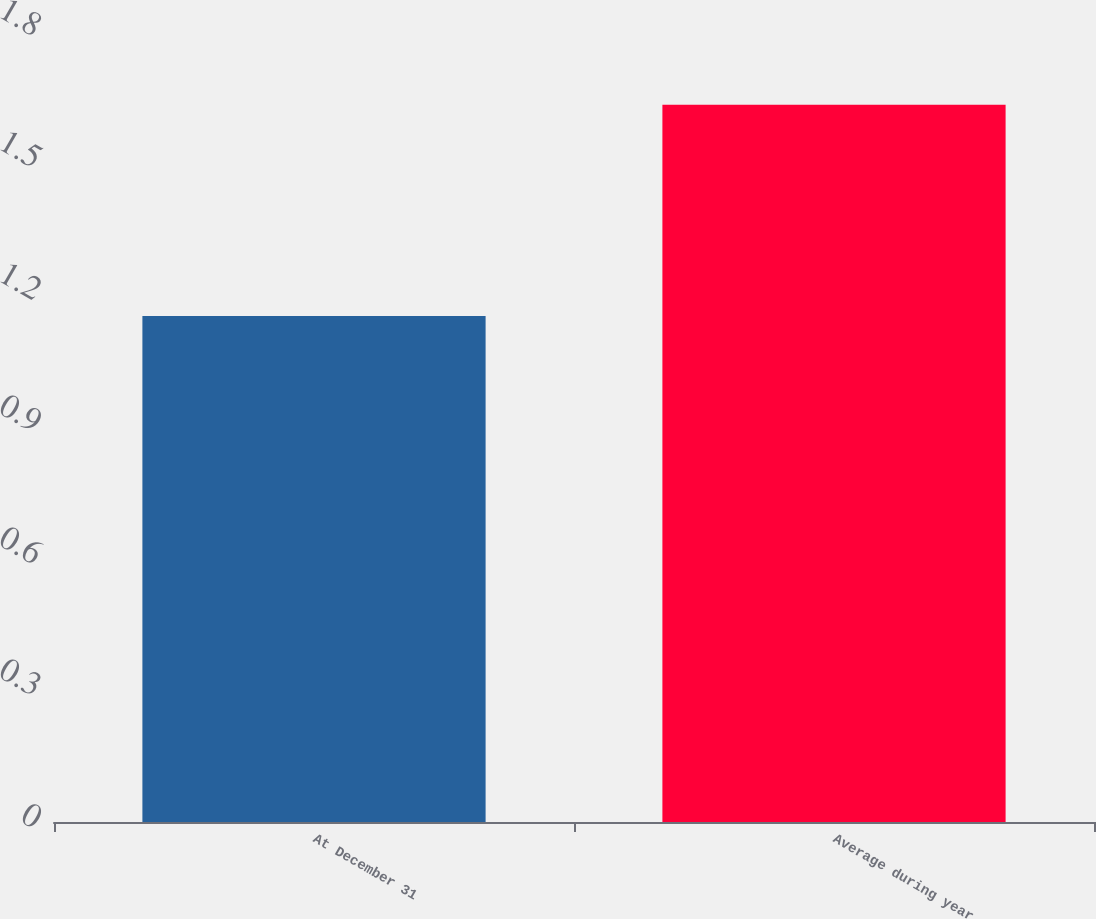<chart> <loc_0><loc_0><loc_500><loc_500><bar_chart><fcel>At December 31<fcel>Average during year<nl><fcel>1.15<fcel>1.63<nl></chart> 